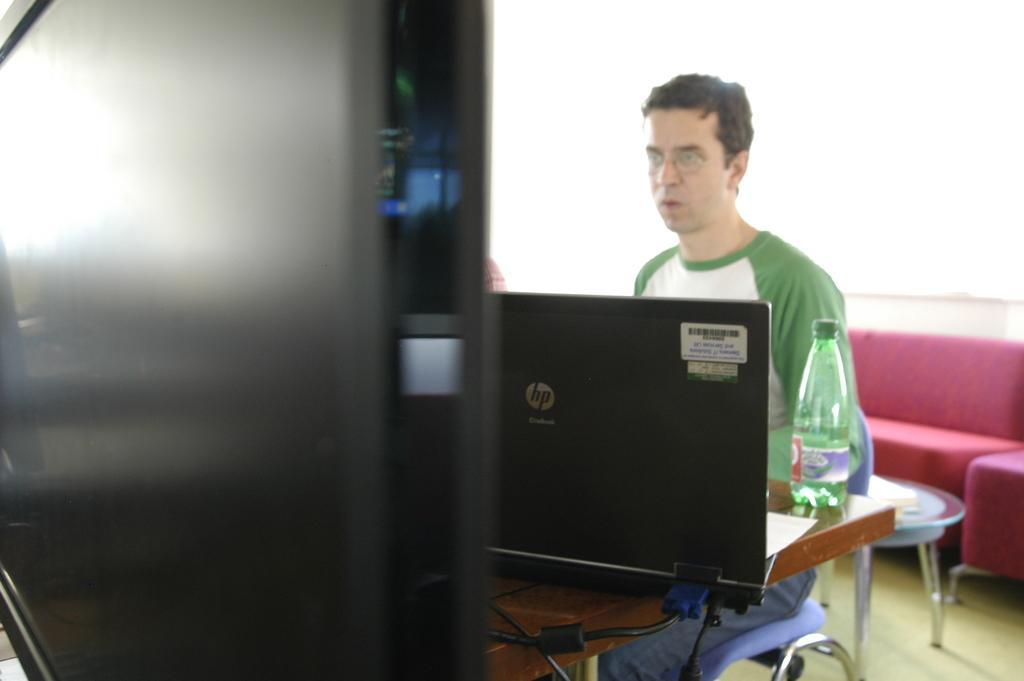What is the main subject of the image? The main subject of the image is a man. What is the man doing in the image? The man is sitting in a chair in the image. What is the man looking at while sitting in the chair? The man is looking into a laptop. What type of muscle can be seen flexing in the image? There is no muscle visible in the image; it features a man sitting in a chair and looking into a laptop. What word is the man typing on the laptop in the image? The image does not provide information about the specific word the man might be typing on the laptop. 